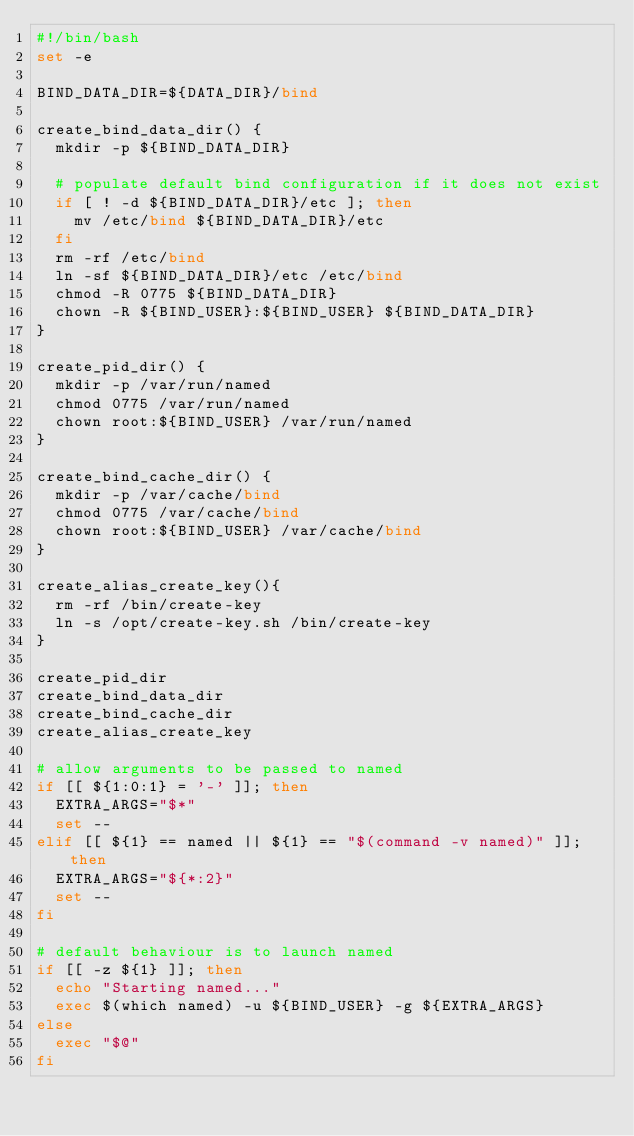Convert code to text. <code><loc_0><loc_0><loc_500><loc_500><_Bash_>#!/bin/bash
set -e

BIND_DATA_DIR=${DATA_DIR}/bind

create_bind_data_dir() {
  mkdir -p ${BIND_DATA_DIR}

  # populate default bind configuration if it does not exist
  if [ ! -d ${BIND_DATA_DIR}/etc ]; then
    mv /etc/bind ${BIND_DATA_DIR}/etc
  fi
  rm -rf /etc/bind
  ln -sf ${BIND_DATA_DIR}/etc /etc/bind
  chmod -R 0775 ${BIND_DATA_DIR}
  chown -R ${BIND_USER}:${BIND_USER} ${BIND_DATA_DIR}
}

create_pid_dir() {
  mkdir -p /var/run/named
  chmod 0775 /var/run/named
  chown root:${BIND_USER} /var/run/named
}

create_bind_cache_dir() {
  mkdir -p /var/cache/bind
  chmod 0775 /var/cache/bind
  chown root:${BIND_USER} /var/cache/bind
}

create_alias_create_key(){
  rm -rf /bin/create-key
  ln -s /opt/create-key.sh /bin/create-key
}

create_pid_dir
create_bind_data_dir
create_bind_cache_dir
create_alias_create_key

# allow arguments to be passed to named
if [[ ${1:0:1} = '-' ]]; then
  EXTRA_ARGS="$*"
  set --
elif [[ ${1} == named || ${1} == "$(command -v named)" ]]; then
  EXTRA_ARGS="${*:2}"
  set --
fi

# default behaviour is to launch named
if [[ -z ${1} ]]; then
  echo "Starting named..."
  exec $(which named) -u ${BIND_USER} -g ${EXTRA_ARGS}
else
  exec "$@"
fi</code> 